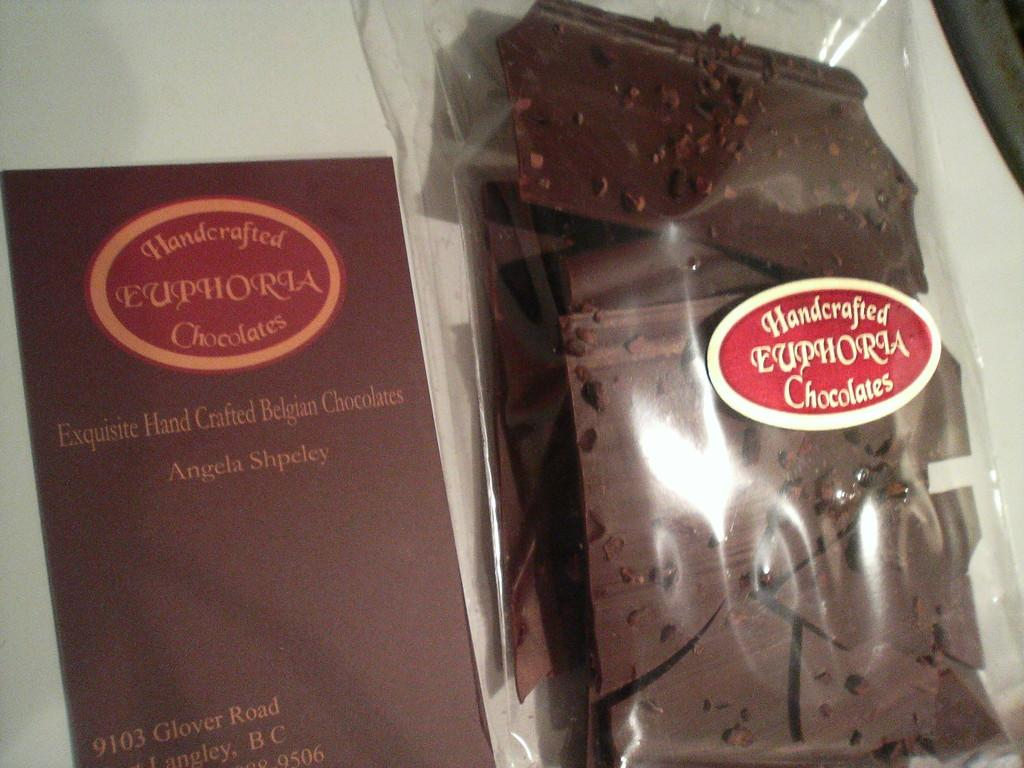<image>
Summarize the visual content of the image. Handcrafted chocolates are in a bag which is sitting in a box. 